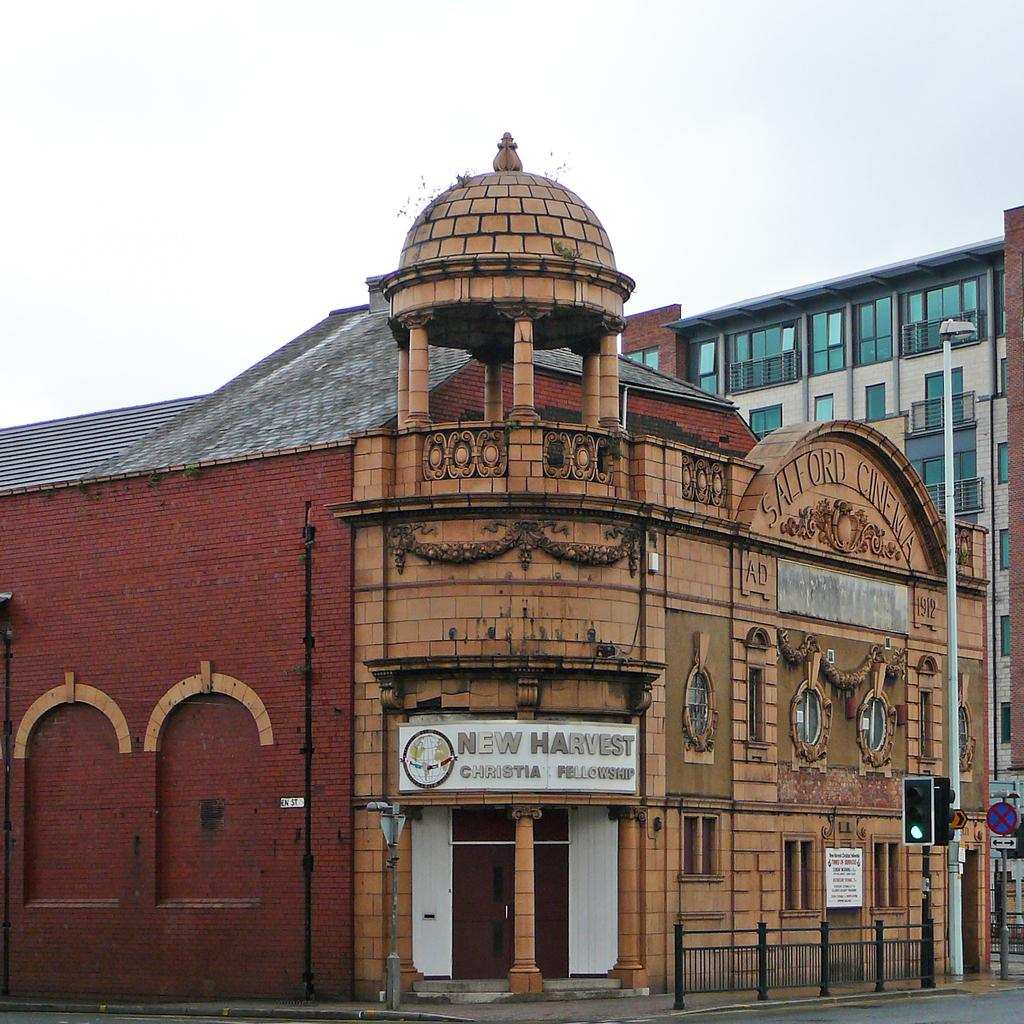What type of structures can be seen in the image? There are buildings in the image. What is located in front of the buildings? There is a traffic signal light, a lamp post, and a metal fence in front of the buildings. What type of line is being used for the selection of the van in the image? There is no van present in the image, and therefore no line or selection process can be observed. 